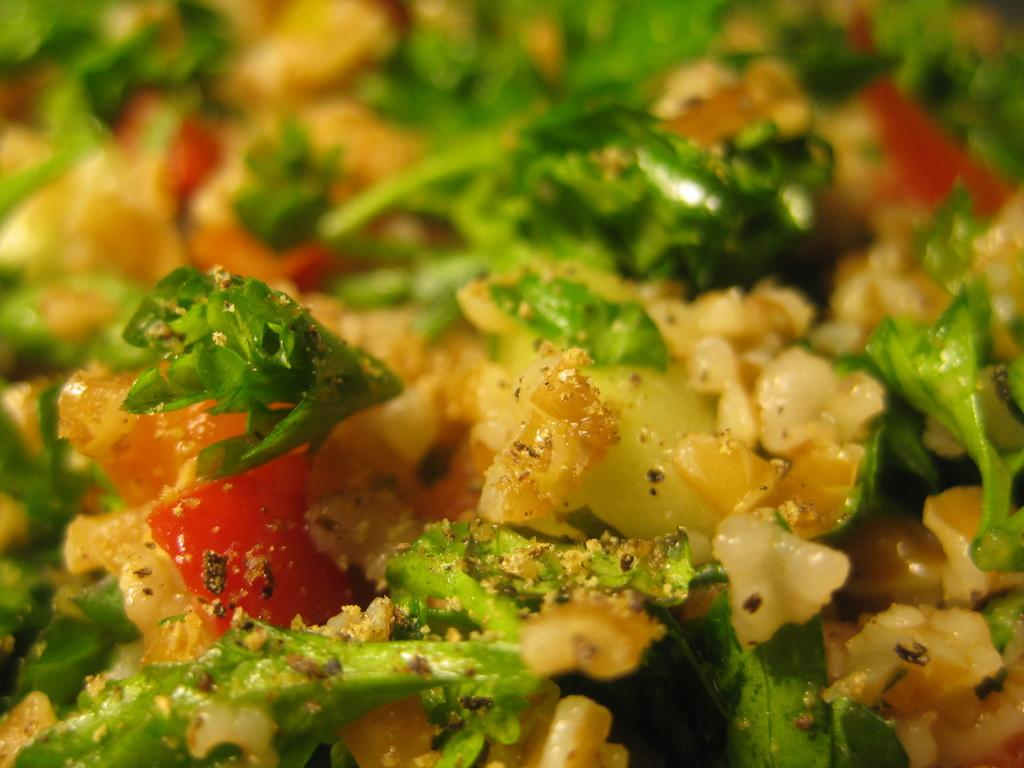What is the main subject of the image? There is a food item in the image. What type of story is being told by the train in the image? There is no train present in the image, and therefore no story being told by a train. 